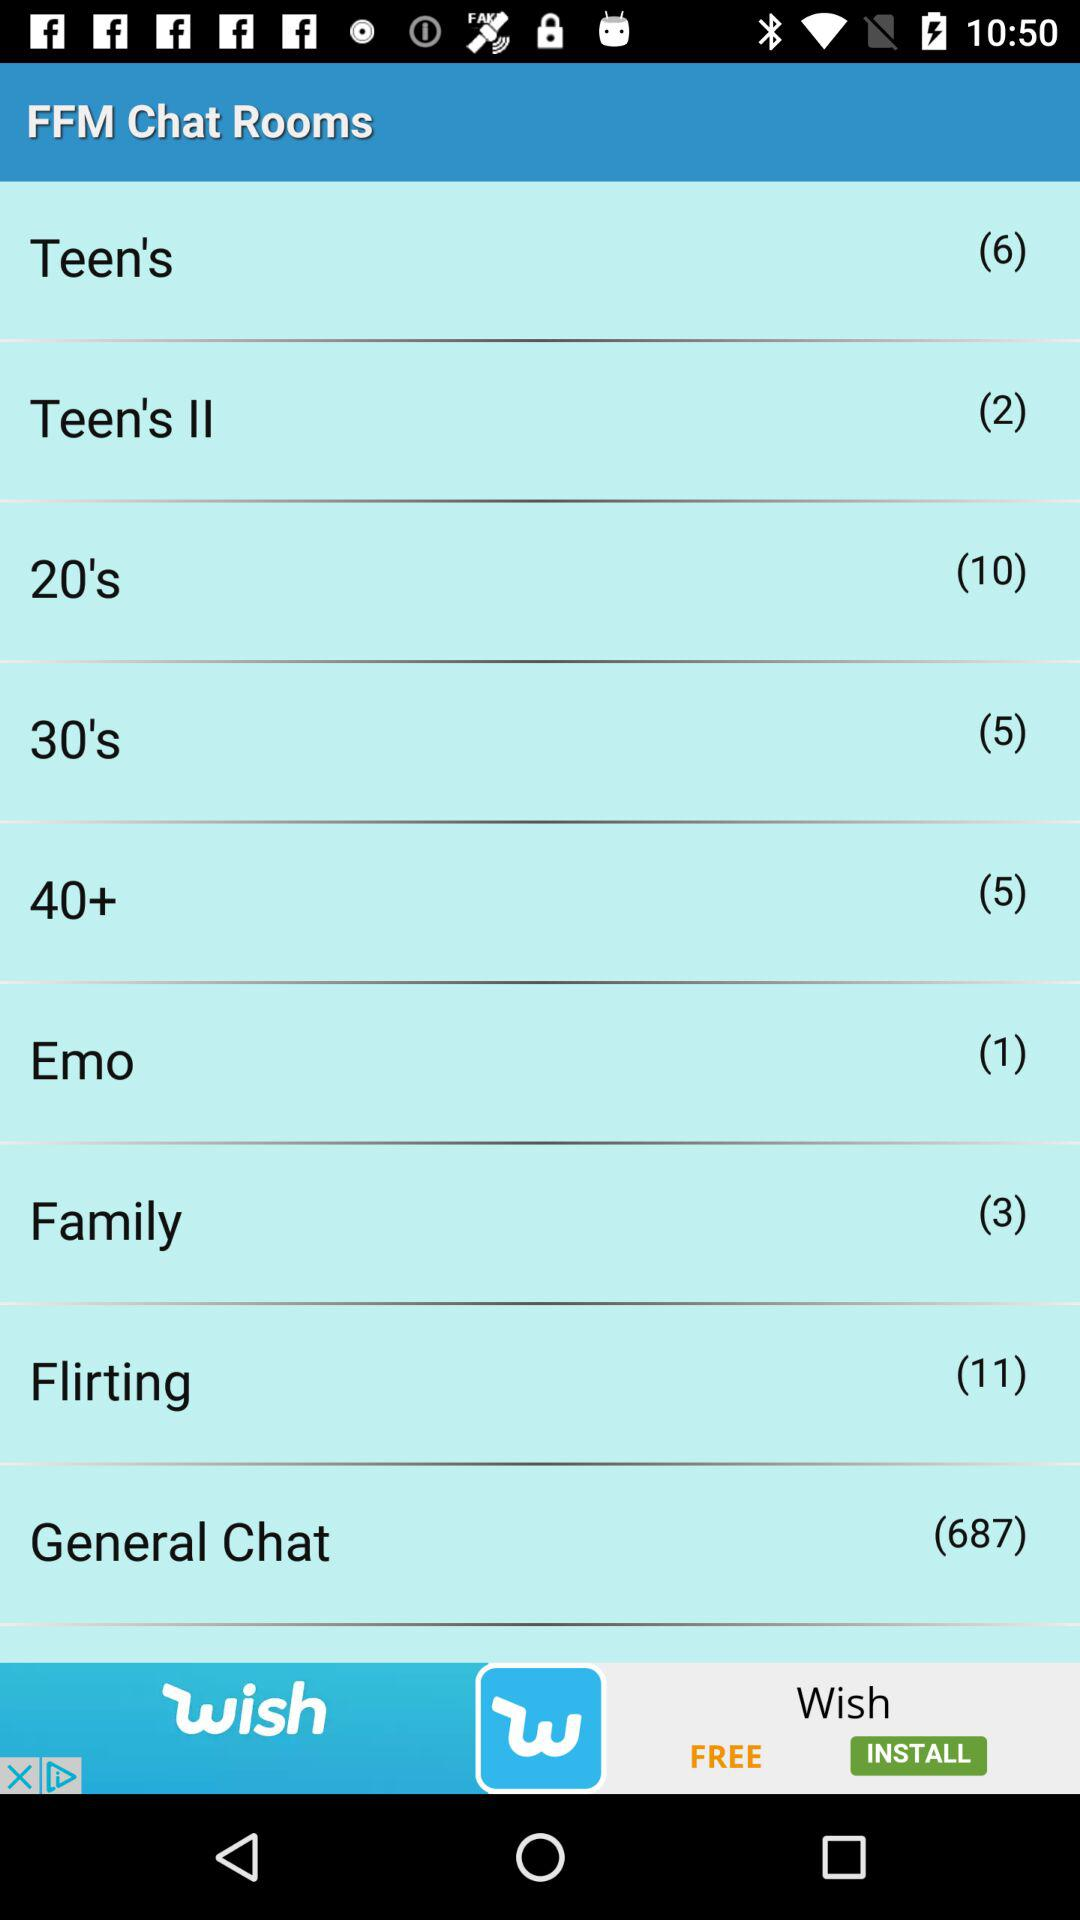How many chat rooms are there in total?
Answer the question using a single word or phrase. 9 